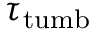Convert formula to latex. <formula><loc_0><loc_0><loc_500><loc_500>\tau _ { t u m b }</formula> 